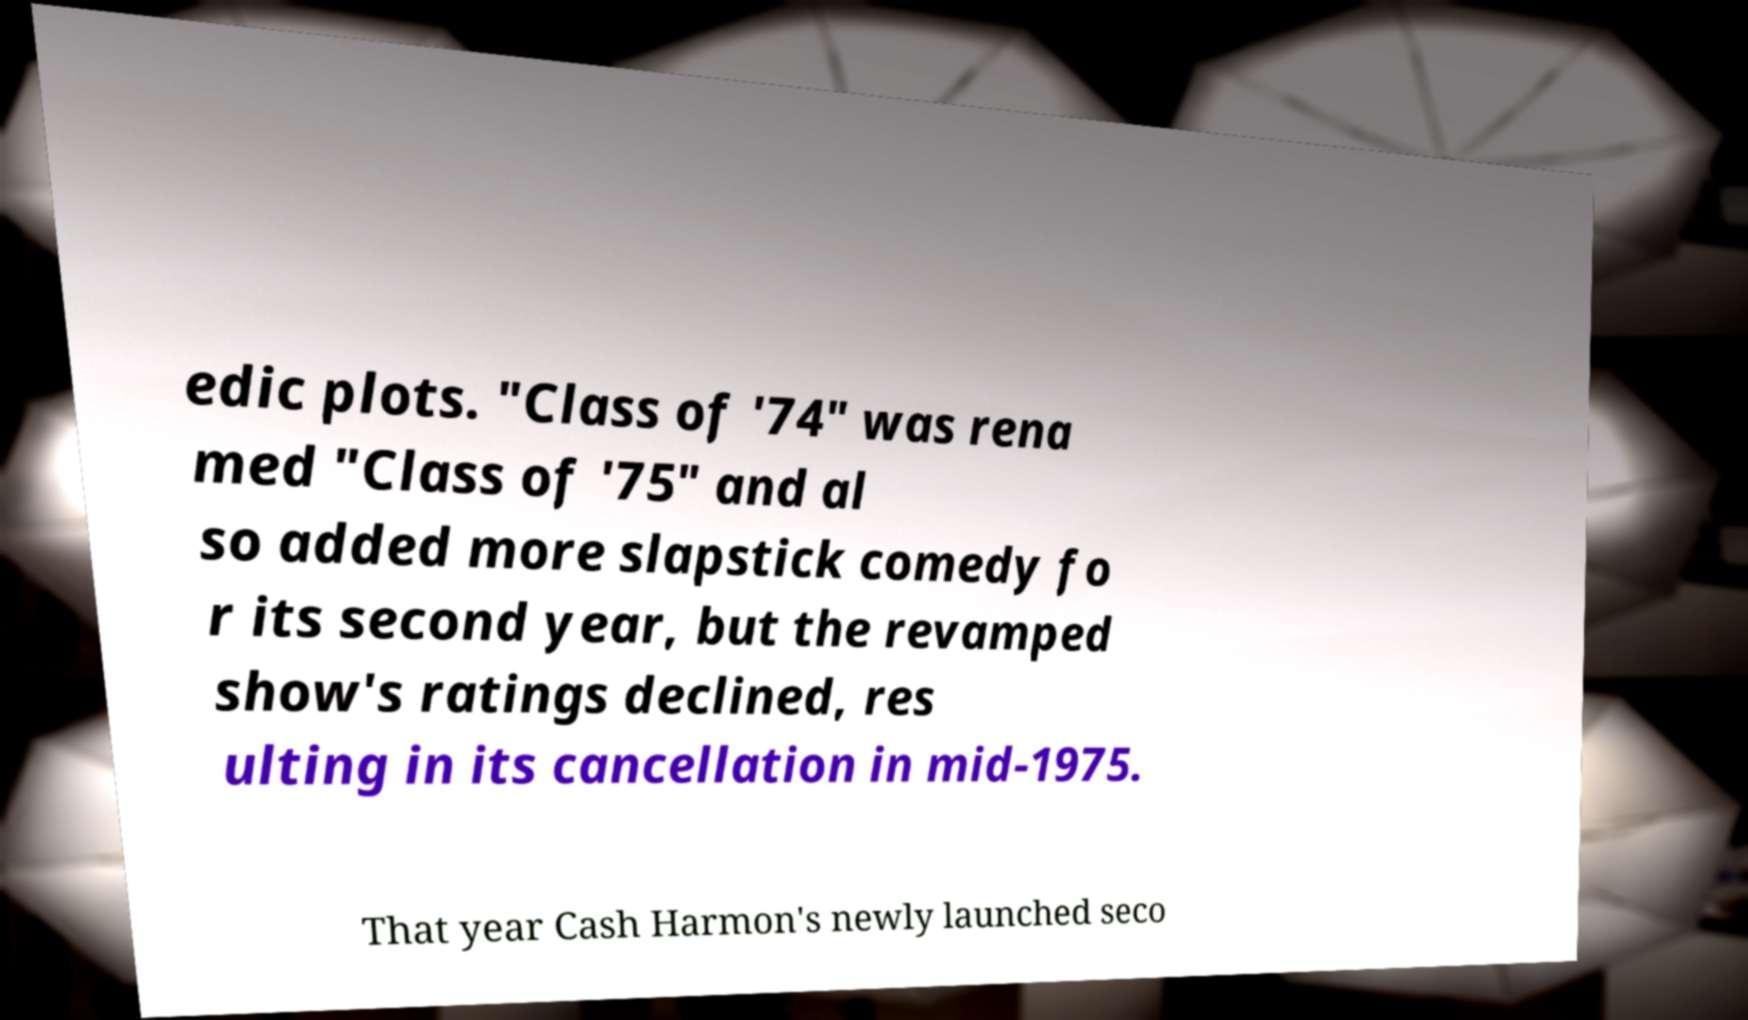Please identify and transcribe the text found in this image. edic plots. "Class of '74" was rena med "Class of '75" and al so added more slapstick comedy fo r its second year, but the revamped show's ratings declined, res ulting in its cancellation in mid-1975. That year Cash Harmon's newly launched seco 